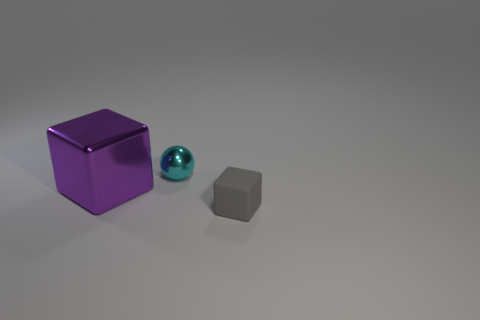Add 3 small gray cubes. How many objects exist? 6 Subtract 1 spheres. How many spheres are left? 0 Subtract all cubes. How many objects are left? 1 Subtract all gray cubes. How many cubes are left? 1 Subtract all purple blocks. Subtract all purple balls. How many blocks are left? 1 Subtract all cyan cylinders. How many purple cubes are left? 1 Subtract all large blocks. Subtract all yellow cubes. How many objects are left? 2 Add 2 large purple things. How many large purple things are left? 3 Add 1 balls. How many balls exist? 2 Subtract 0 yellow spheres. How many objects are left? 3 